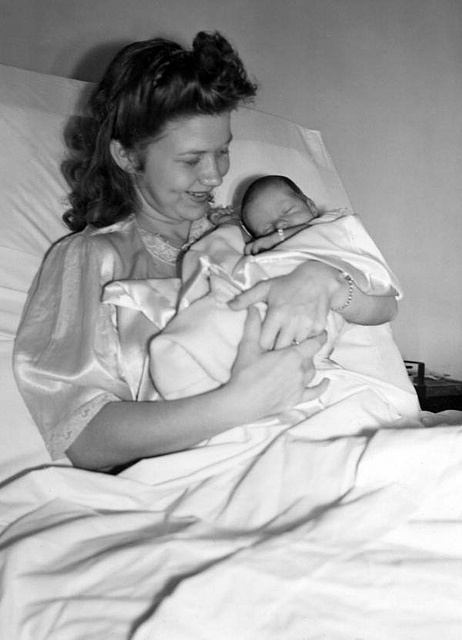Describe the objects in this image and their specific colors. I can see people in gray, darkgray, lightgray, black, and dimgray tones, bed in gray, lightgray, darkgray, and black tones, and bed in gray, darkgray, lightgray, and black tones in this image. 